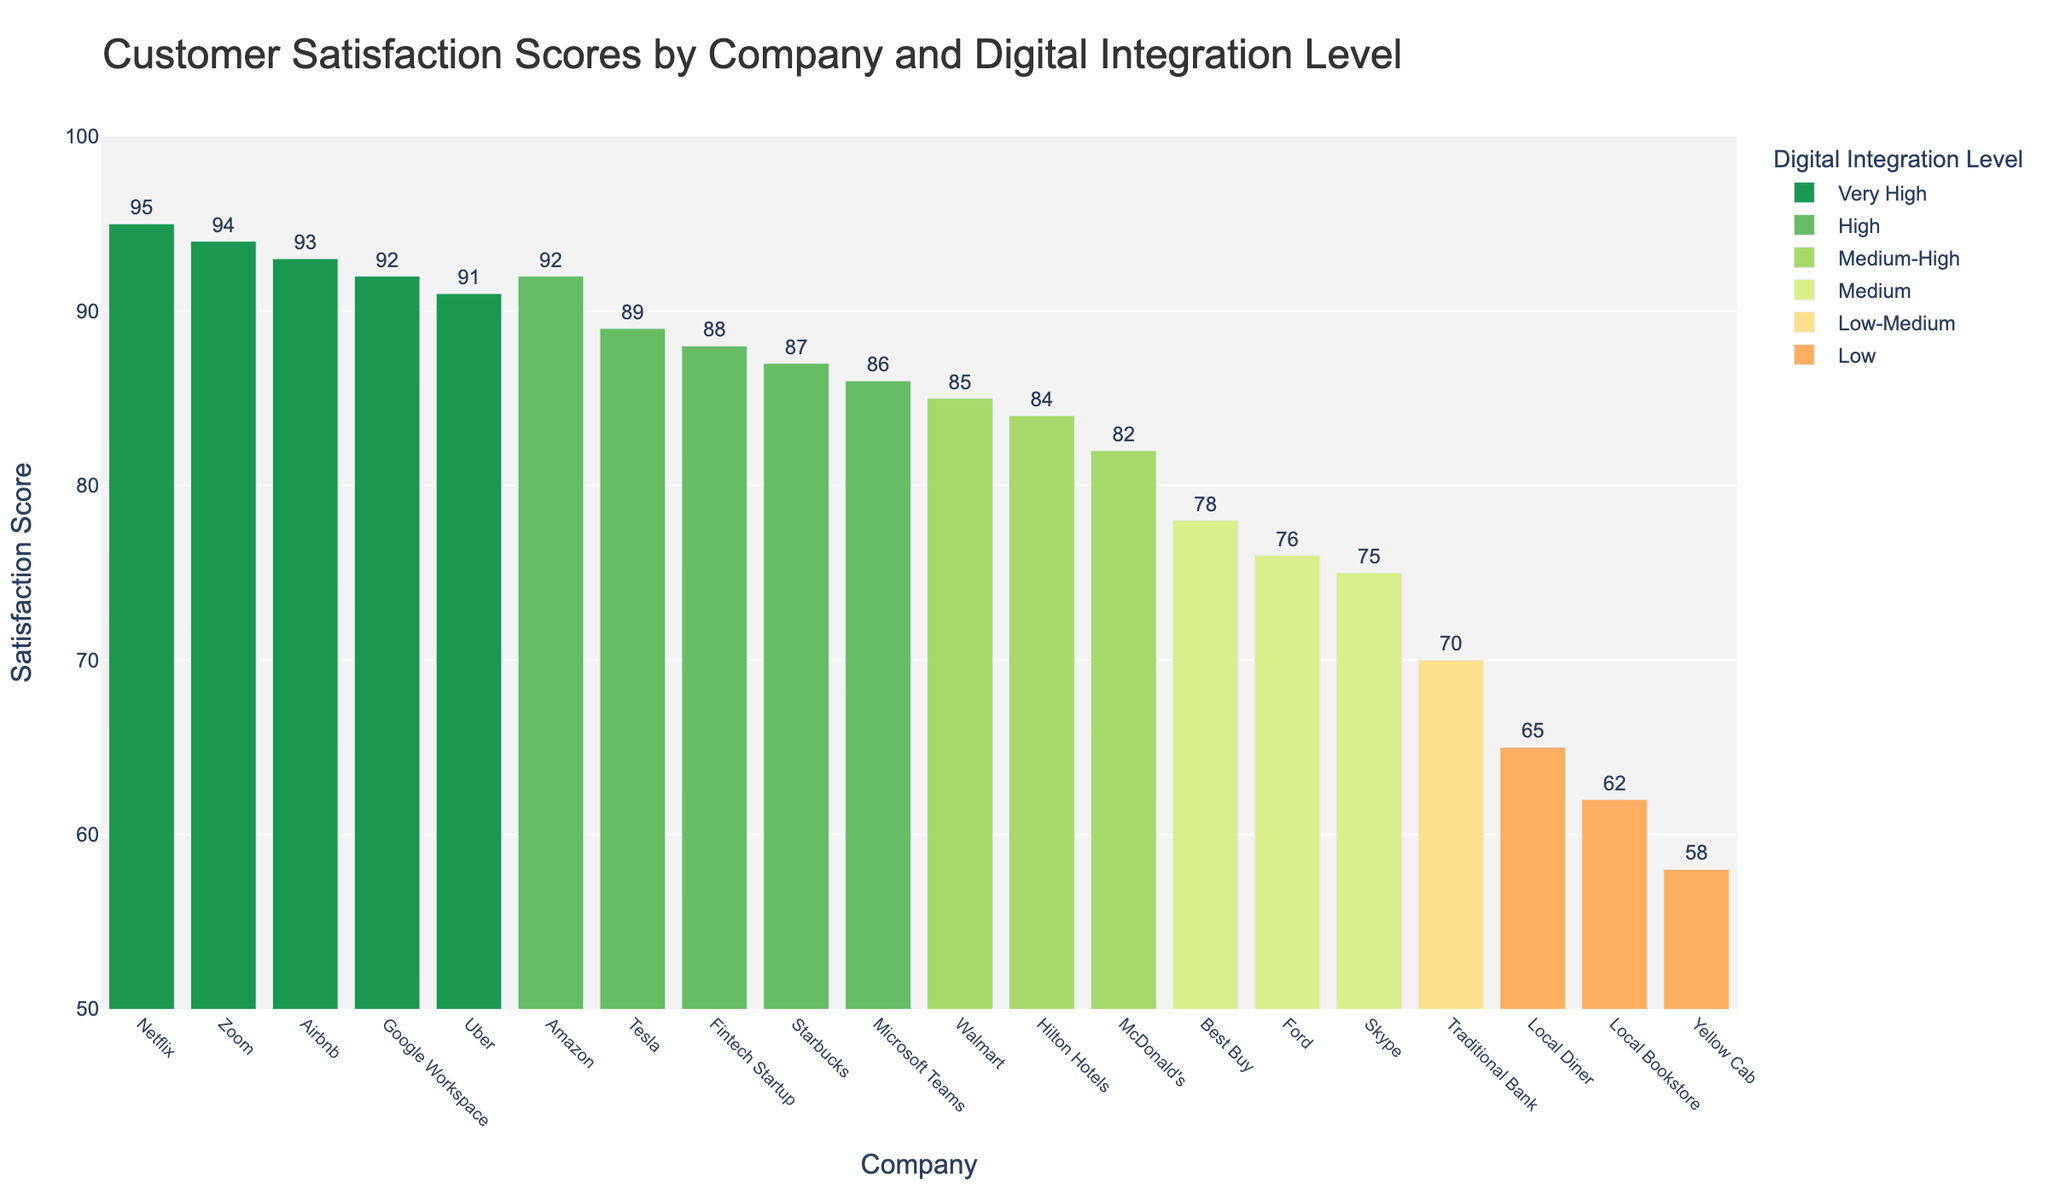Which company has the lowest customer satisfaction score? By observing the height of the bars, the company with the shortest bar represents the lowest score. Yellow Cab has the shortest bar with a satisfaction score of 58.
Answer: Yellow Cab What is the difference in customer satisfaction scores between Airbnb and a Traditional Bank? Airbnb has a satisfaction score of 93, and Traditional Bank has 70. The difference is 93 - 70 = 23.
Answer: 23 Which companies have a customer satisfaction score greater than 90? By looking at the bars that exceed the 90 mark on the y-axis, the companies are Amazon (92), Netflix (95), Uber (91), Airbnb (93), Zoom (94), and Google Workspace (92).
Answer: Amazon, Netflix, Uber, Airbnb, Zoom, Google Workspace What's the average customer satisfaction score for companies with "Very High" digital integration? The companies with "Very High" integration levels are Netflix (95), Uber (91), Airbnb (93), Zoom (94), and Google Workspace (92). Their average is (95 + 91 + 93 + 94 + 92) / 5 = 93.
Answer: 93 Which has higher customer satisfaction: Best Buy or Starbucks? Best Buy has a score of 78, and Starbucks has a score of 87. Starbucks has the higher score.
Answer: Starbucks How does the customer satisfaction score of Walmart compare to McDonald's? Walmart has a score of 85, and McDonald's has 82. Hence, Walmart has a slightly higher score.
Answer: Walmart What's the median customer satisfaction score for the companies shown in the chart? To find the median, list the scores in ascending order (58, 62, 65, 70, 75, 76, 78, 82, 84, 85, 86, 87, 88, 89, 91, 92, 92, 93, 94, 95). Since there are 20 scores, the median is the average of the 10th and 11th scores: (85 + 86) / 2 = 85.5.
Answer: 85.5 How many companies have a "Low" or "Low-Medium" digital integration level? Counting the companies with these colors, there are Local Bookstore (Low), Yellow Cab (Low), Local Diner (Low), and Traditional Bank (Low-Medium), hence there are 4 companies.
Answer: 4 Which type of digital integration level tends to have the highest customer satisfaction scores? Comparing the height and colors of bars, the "Very High" digital integration level appears to have the highest scores, with examples such as Netflix (95), Uber (91), Airbnb (93), Zoom (94), and Google Workspace (92).
Answer: Very High 